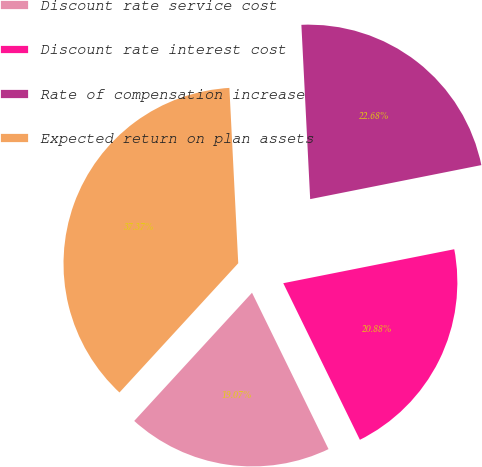Convert chart to OTSL. <chart><loc_0><loc_0><loc_500><loc_500><pie_chart><fcel>Discount rate service cost<fcel>Discount rate interest cost<fcel>Rate of compensation increase<fcel>Expected return on plan assets<nl><fcel>19.07%<fcel>20.88%<fcel>22.68%<fcel>37.37%<nl></chart> 